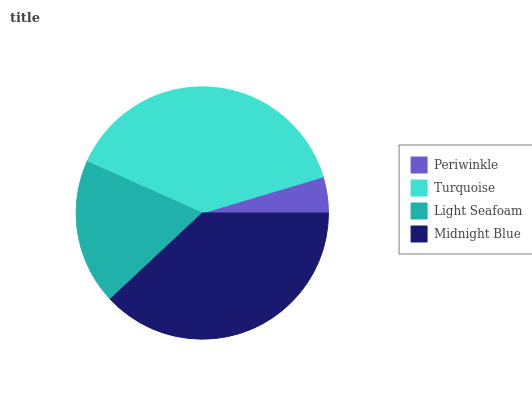Is Periwinkle the minimum?
Answer yes or no. Yes. Is Turquoise the maximum?
Answer yes or no. Yes. Is Light Seafoam the minimum?
Answer yes or no. No. Is Light Seafoam the maximum?
Answer yes or no. No. Is Turquoise greater than Light Seafoam?
Answer yes or no. Yes. Is Light Seafoam less than Turquoise?
Answer yes or no. Yes. Is Light Seafoam greater than Turquoise?
Answer yes or no. No. Is Turquoise less than Light Seafoam?
Answer yes or no. No. Is Midnight Blue the high median?
Answer yes or no. Yes. Is Light Seafoam the low median?
Answer yes or no. Yes. Is Light Seafoam the high median?
Answer yes or no. No. Is Turquoise the low median?
Answer yes or no. No. 